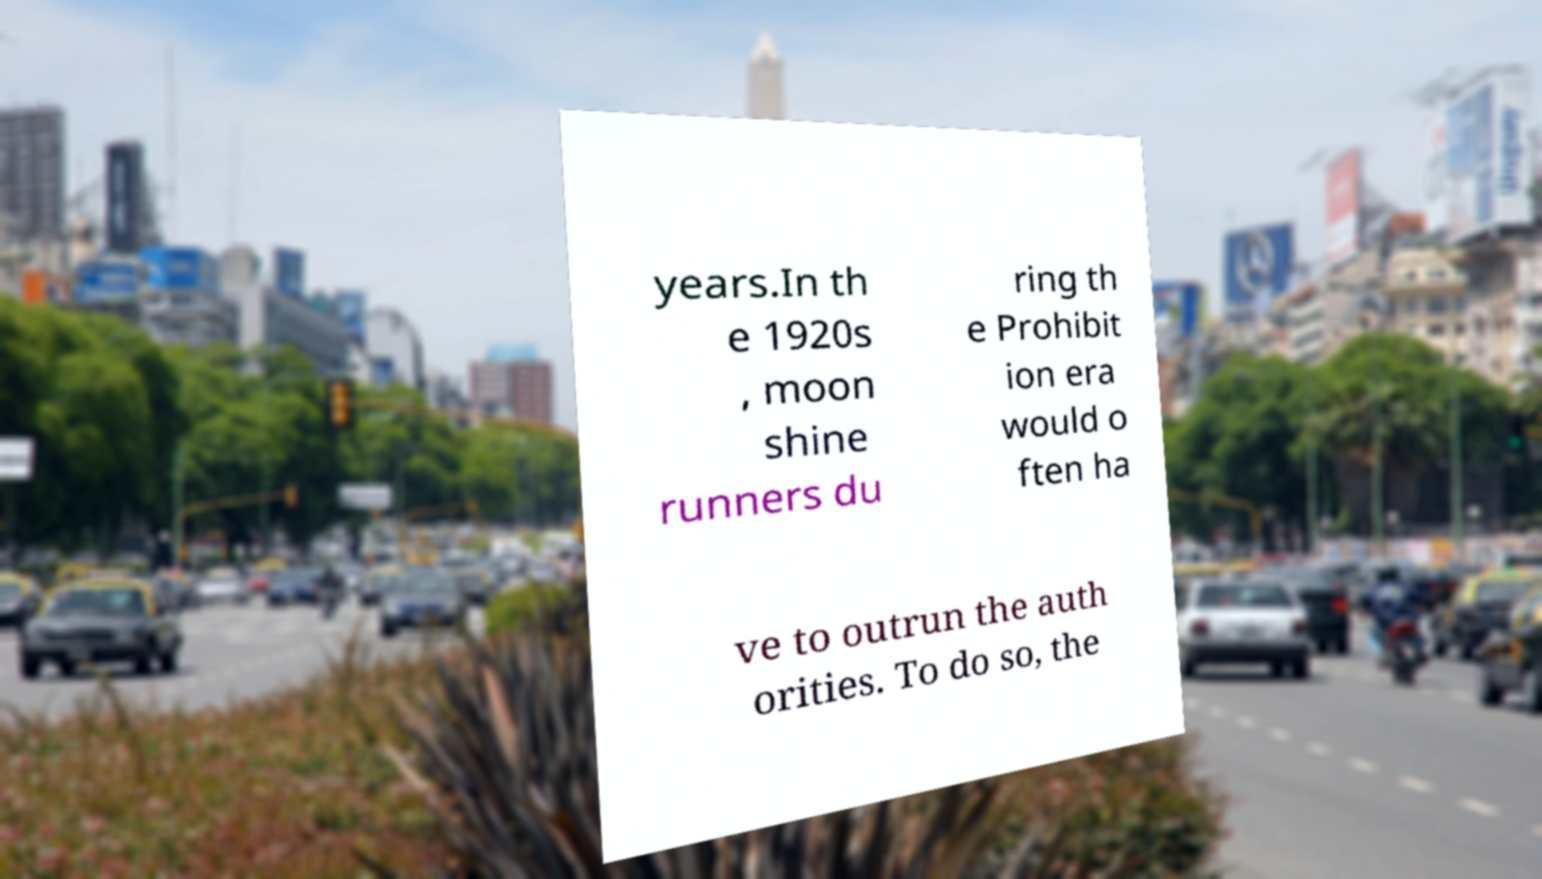Please read and relay the text visible in this image. What does it say? years.In th e 1920s , moon shine runners du ring th e Prohibit ion era would o ften ha ve to outrun the auth orities. To do so, the 